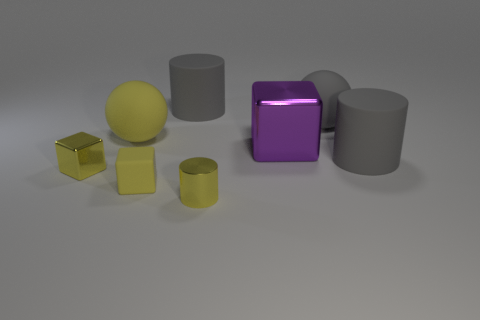There is another tiny block that is the same color as the small matte cube; what is it made of?
Offer a very short reply. Metal. What number of spheres are gray things or big things?
Provide a short and direct response. 2. There is a rubber cylinder that is left of the tiny yellow metallic object that is in front of the small matte thing; what color is it?
Give a very brief answer. Gray. There is a purple thing; what shape is it?
Your answer should be very brief. Cube. There is a metallic cube right of the yellow matte cube; does it have the same size as the large yellow sphere?
Offer a terse response. Yes. Are there any large gray spheres that have the same material as the yellow ball?
Your answer should be compact. Yes. What number of objects are either gray matte cylinders to the right of the small metallic cylinder or small yellow metal objects?
Provide a succinct answer. 3. Is there a shiny thing?
Your response must be concise. Yes. What is the shape of the metal object that is both behind the tiny yellow metal cylinder and on the left side of the large purple metal object?
Give a very brief answer. Cube. There is a yellow cylinder on the left side of the gray matte sphere; how big is it?
Provide a succinct answer. Small. 